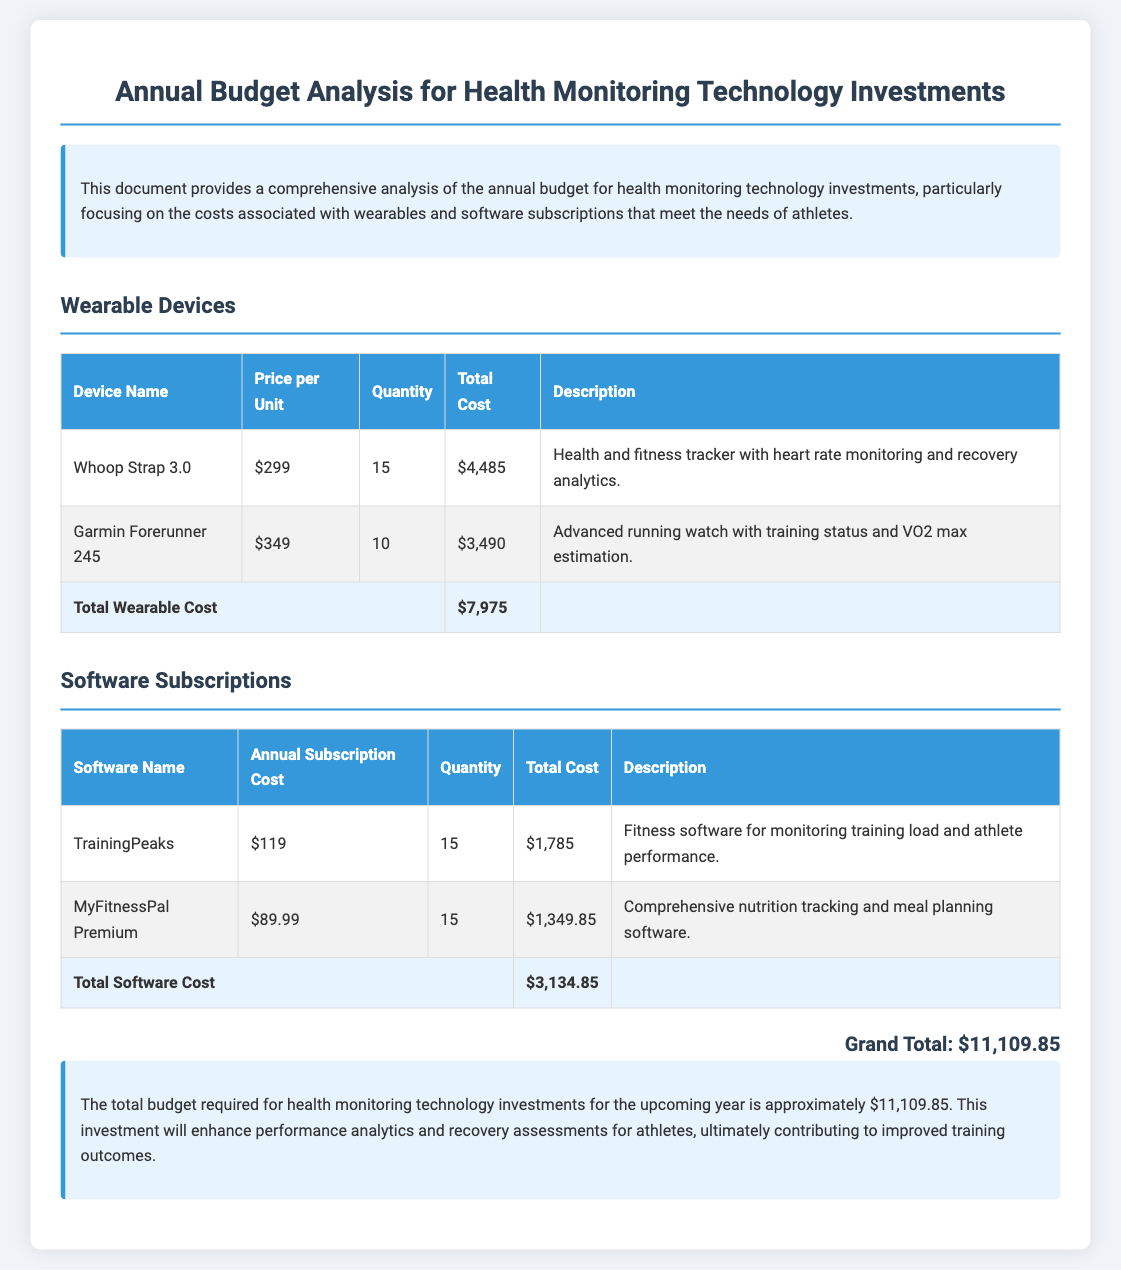What is the total cost for wearables? The total cost for wearables is explicitly stated in the document under the "Total Wearable Cost" row.
Answer: $7,975 How many Whoop Straps were purchased? The quantity of Whoop Straps purchased is mentioned in the corresponding row of the table.
Answer: 15 What is the annual subscription cost for TrainingPeaks? The document specifies the annual subscription cost of TrainingPeaks in the software subscriptions table.
Answer: $119 What percentage of the total budget is allocated to software subscriptions? To determine this, calculate the proportion of the total software cost to the grand total, ($3,134.85 / $11,109.85) * 100.
Answer: Approximately 28.2% Which wearable device has the highest individual price? The document lists the prices for each wearable device, allowing for comparison.
Answer: Garmin Forerunner 245 What is the total budget for health monitoring technology investments? The grand total specifically states the overall budget requirement for the upcoming year.
Answer: $11,109.85 What is the description of the Garmin Forerunner 245? The document provides a description of each device in its respective row, highlighting its features.
Answer: Advanced running watch with training status and VO2 max estimation How many MyFitnessPal Premium subscriptions were purchased? The quantity of MyFitnessPal Premium subscriptions can be found in the software subscriptions table.
Answer: 15 What do the final conclusions emphasize about the investments? The conclusion section provides an overview of the expected outcomes from the investments, which can be summarized.
Answer: Enhanced performance analytics and recovery assessments for athletes 